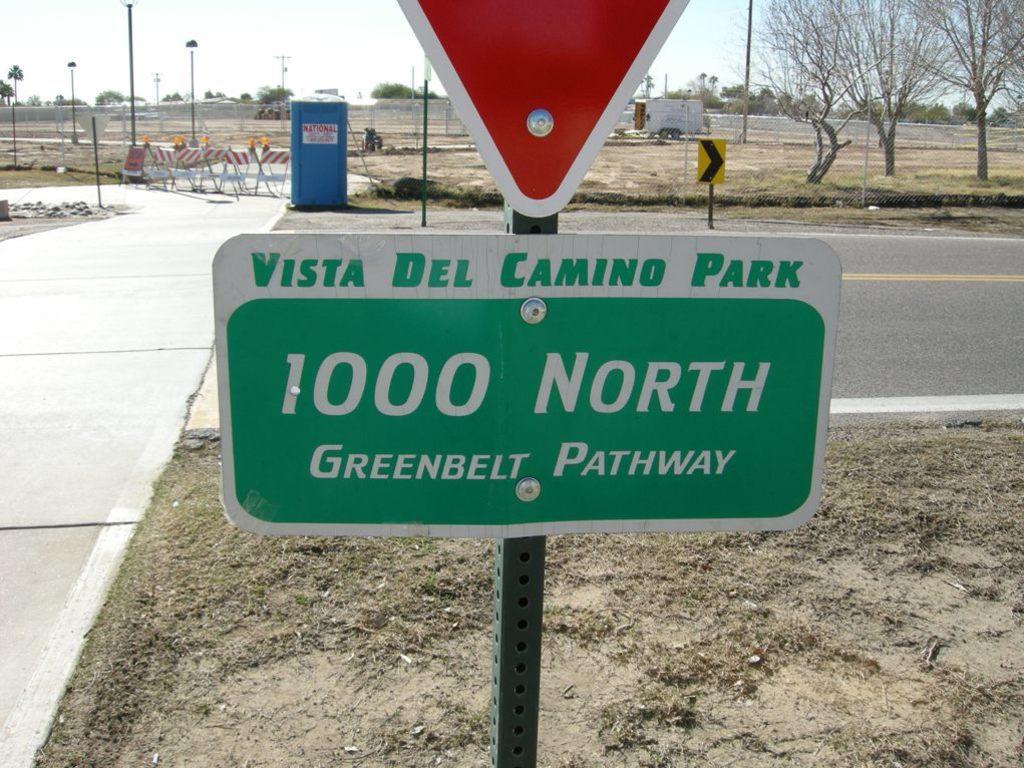What is the address?
Offer a very short reply. 1000 north greenbelt pathway. 